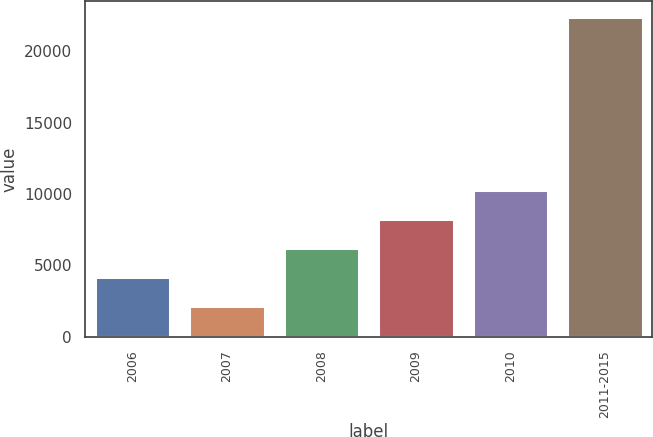Convert chart to OTSL. <chart><loc_0><loc_0><loc_500><loc_500><bar_chart><fcel>2006<fcel>2007<fcel>2008<fcel>2009<fcel>2010<fcel>2011-2015<nl><fcel>4175.2<fcel>2149<fcel>6201.4<fcel>8227.6<fcel>10253.8<fcel>22411<nl></chart> 